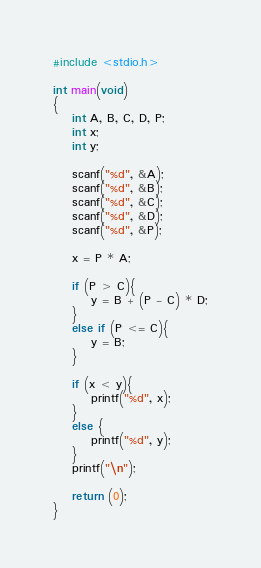<code> <loc_0><loc_0><loc_500><loc_500><_C_>#include <stdio.h>

int main(void)
{
	int A, B, C, D, P;
	int x;
	int y;
	
	scanf("%d", &A);
	scanf("%d", &B);
	scanf("%d", &C);
	scanf("%d", &D);
	scanf("%d", &P);
	
	x = P * A;
	
	if (P > C){
		y = B + (P - C) * D;
	}
	else if (P <= C){
		y = B;
	}
	
	if (x < y){
		printf("%d", x);
	}
	else {
		printf("%d", y);
	}
	printf("\n");
	
	return (0);
}</code> 